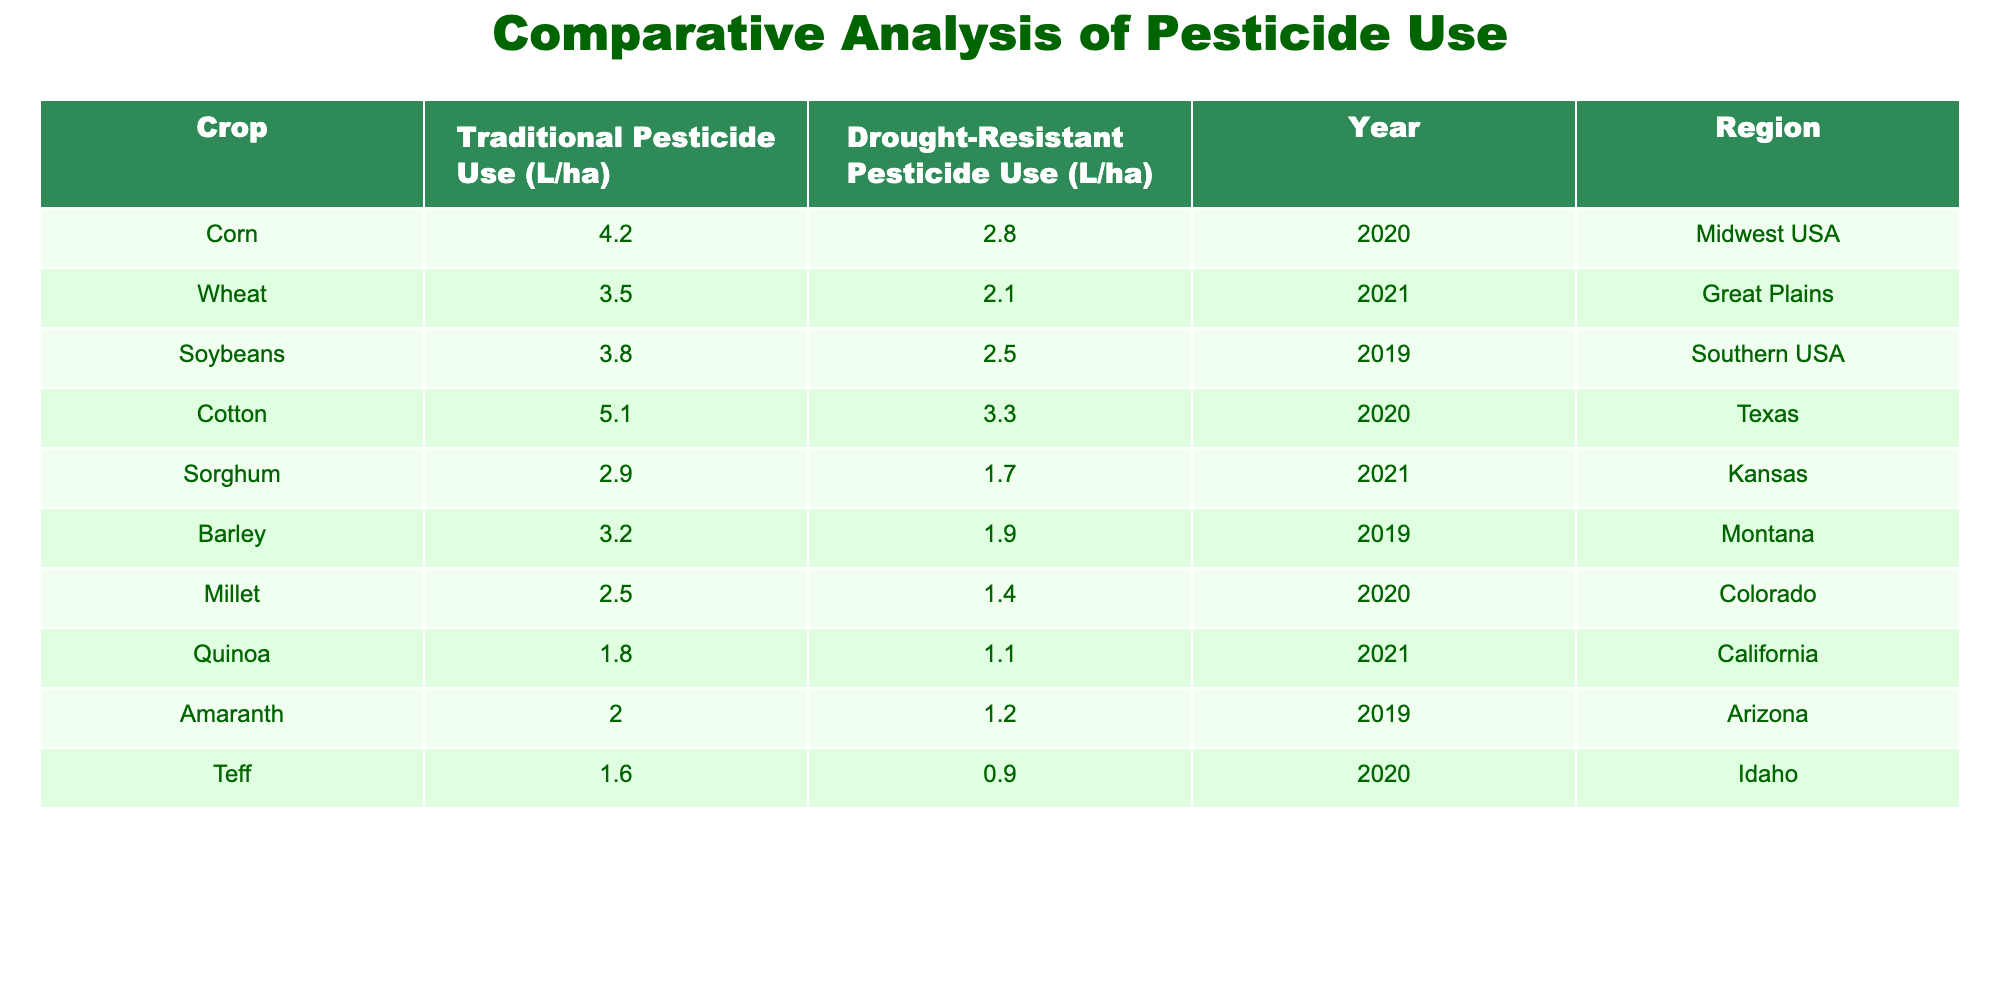What is the pesticide use for Corn in traditional farming? The table shows that the traditional pesticide use for Corn is 4.2 L/ha.
Answer: 4.2 L/ha What is the pesticide use for Quinoa in drought-resistant farming? The table indicates that the pesticide use for Quinoa in drought-resistant farming is 1.1 L/ha.
Answer: 1.1 L/ha Which crop has the highest pesticide use in traditional farming? By examining the table, Corn has the highest traditional pesticide use at 4.2 L/ha.
Answer: Corn What is the difference in pesticide use between traditional and drought-resistant farming for Cotton? For Cotton, traditional pesticide use is 5.1 L/ha and drought-resistant use is 3.3 L/ha. The difference is 5.1 - 3.3 = 1.8 L/ha.
Answer: 1.8 L/ha What is the average pesticide use in traditional farming across all crops listed? The traditional pesticide uses are 4.2, 3.5, 3.8, 5.1, 2.9, 3.2, 2.5, 1.8, 2.0, and 1.6 L/ha. The sum is 25.6 L/ha, and there are 10 crops, so the average is 25.6 / 10 = 2.56 L/ha.
Answer: 2.56 L/ha Which region has the lowest pesticide use in drought-resistant farming? The table shows the following drought-resistant pesticide uses: 2.8 (Midwest), 2.1 (Great Plains), 2.5 (Southern USA), 3.3 (Texas), 1.7 (Kansas), 1.9 (Montana), 1.4 (Colorado), 1.1 (California), 1.2 (Arizona), and 0.9 (Idaho). The lowest is 0.9 L/ha in Idaho.
Answer: Idaho Is the traditional pesticide use for Sorghum greater than for Teff? The traditional pesticide use for Sorghum is 2.9 L/ha, and for Teff, it is 1.6 L/ha. Since 2.9 > 1.6, the answer is yes.
Answer: Yes Which crop has the largest reduction in pesticide use from traditional to drought-resistant farming? The reductions are as follows: Corn (1.4), Wheat (1.4), Soybeans (1.3), Cotton (1.8), Sorghum (1.2), Barley (1.3), Millet (1.1), Quinoa (0.7), Amaranth (0.8), Teff (0.7). Cotton shows the largest reduction of 1.8 L/ha.
Answer: Cotton What percentage of pesticide use was reduced for Wheat in drought-resistant farming compared to traditional farming? Traditional use for Wheat is 3.5 L/ha and drought-resistant use is 2.1 L/ha. The reduction is 3.5 - 2.1 = 1.4 L/ha. To find the percentage reduction: (1.4 / 3.5) * 100 = 40%.
Answer: 40% Among all the crops listed, which has the most balanced pesticide use between traditional and drought-resistant methods? Looking at the differences, Corn (1.4), Wheat (1.4), Soybeans (1.3), and Barley (1.3) show smaller gaps, indicating more balanced use. The precise figures are tied between Corn and Wheat with a 1.4 L/ha difference.
Answer: Corn and Wheat 